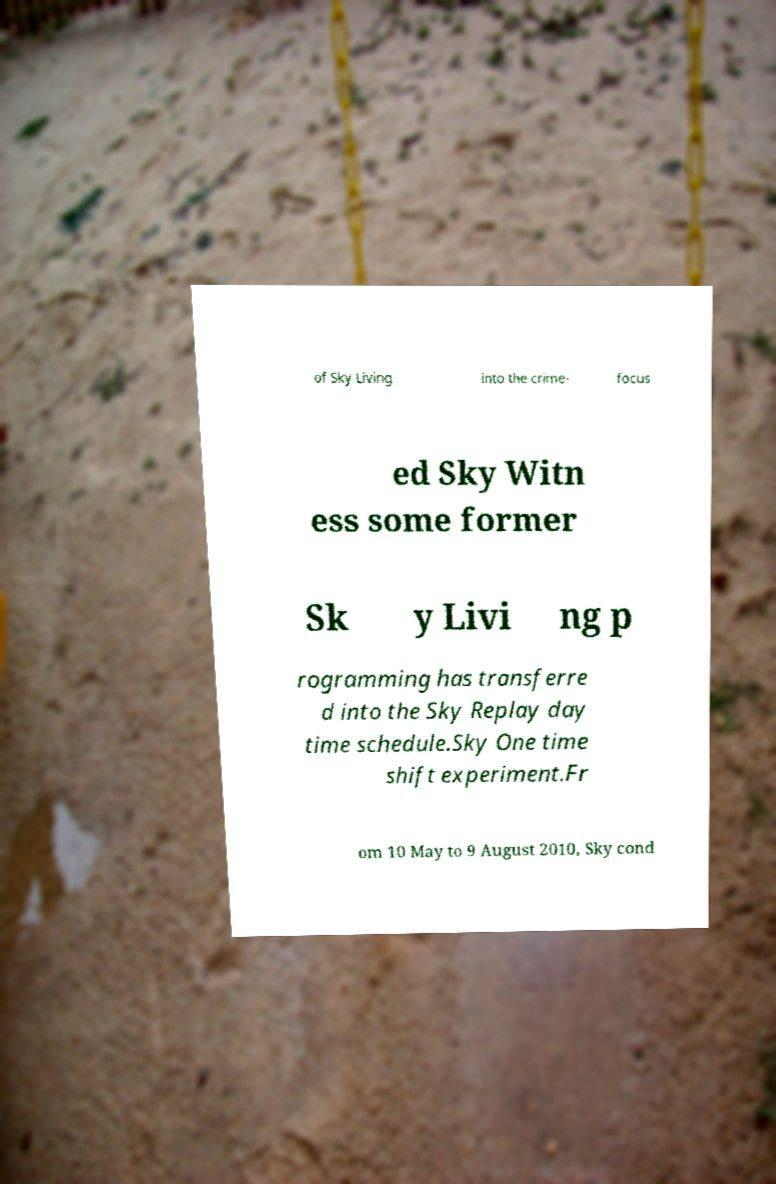Can you accurately transcribe the text from the provided image for me? of Sky Living into the crime- focus ed Sky Witn ess some former Sk y Livi ng p rogramming has transferre d into the Sky Replay day time schedule.Sky One time shift experiment.Fr om 10 May to 9 August 2010, Sky cond 